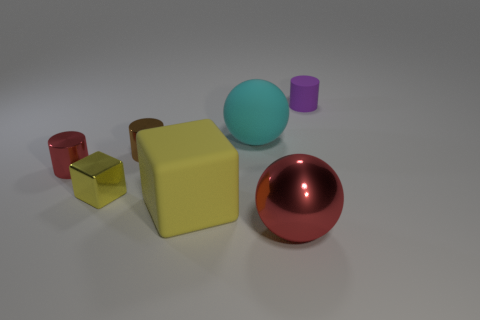Subtract all tiny shiny cylinders. How many cylinders are left? 1 Add 1 tiny red objects. How many objects exist? 8 Subtract all purple cylinders. How many cylinders are left? 2 Subtract all cubes. How many objects are left? 5 Subtract 1 blocks. How many blocks are left? 1 Subtract all blue blocks. Subtract all gray spheres. How many blocks are left? 2 Add 7 brown metallic spheres. How many brown metallic spheres exist? 7 Subtract 0 gray spheres. How many objects are left? 7 Subtract all blue cylinders. How many cyan balls are left? 1 Subtract all purple cylinders. Subtract all big yellow things. How many objects are left? 5 